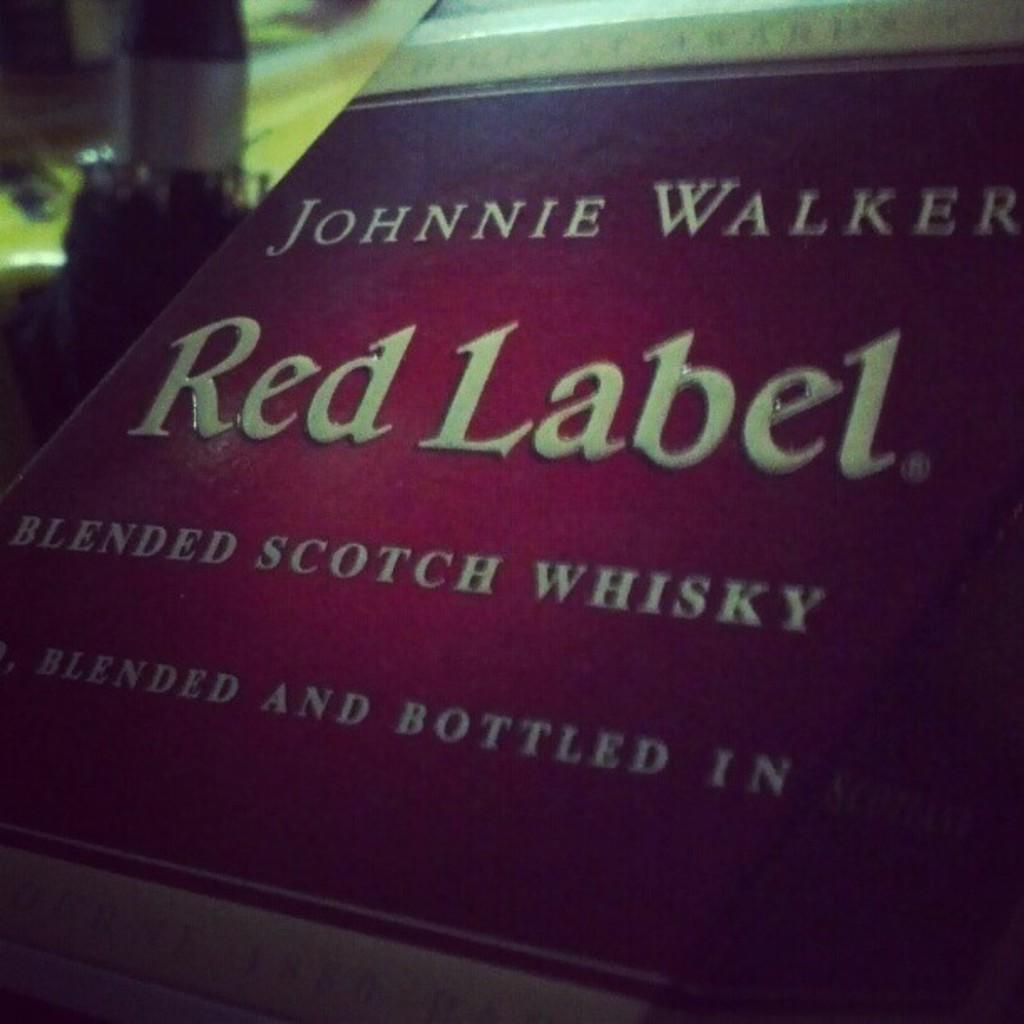<image>
Create a compact narrative representing the image presented. A label from Red Label Blended Scotch Whisky is displayed 